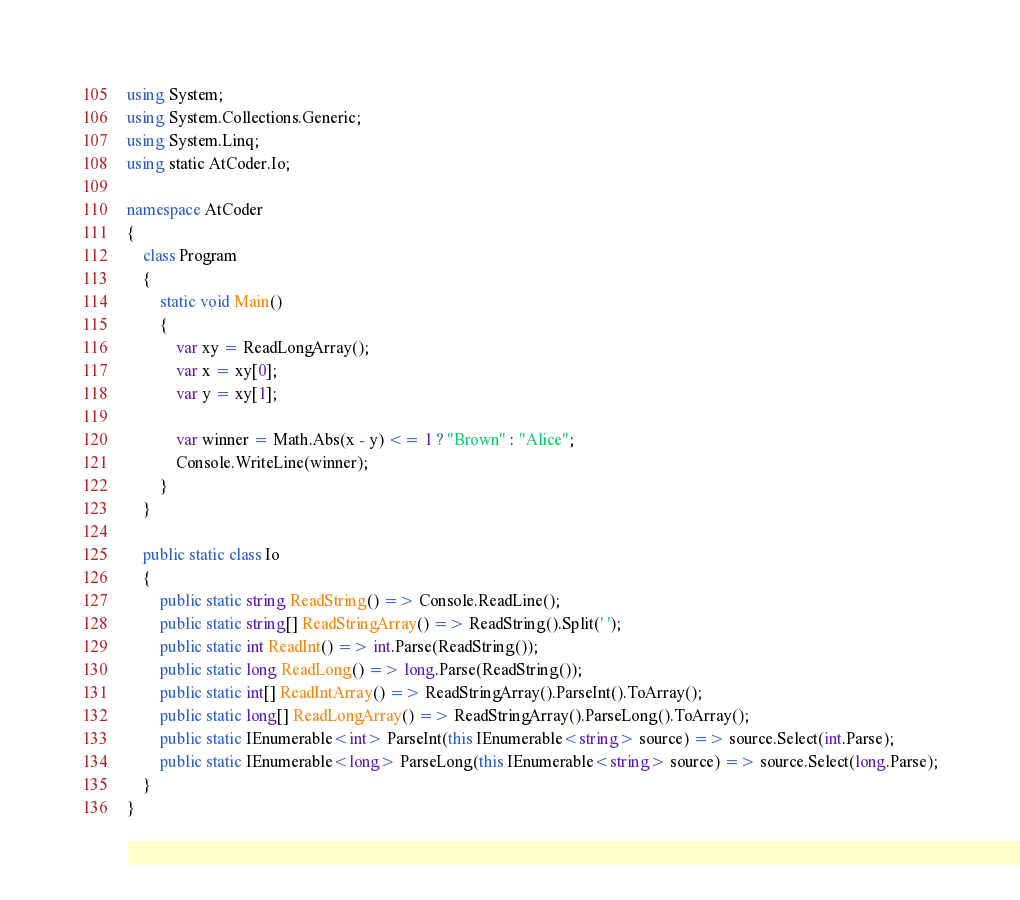Convert code to text. <code><loc_0><loc_0><loc_500><loc_500><_C#_>using System;
using System.Collections.Generic;
using System.Linq;
using static AtCoder.Io;

namespace AtCoder
{
    class Program
    {
        static void Main()
        {
            var xy = ReadLongArray();
            var x = xy[0];
            var y = xy[1];

            var winner = Math.Abs(x - y) <= 1 ? "Brown" : "Alice";
            Console.WriteLine(winner);
        }
    }

    public static class Io
    {
        public static string ReadString() => Console.ReadLine();
        public static string[] ReadStringArray() => ReadString().Split(' ');
        public static int ReadInt() => int.Parse(ReadString());
        public static long ReadLong() => long.Parse(ReadString());
        public static int[] ReadIntArray() => ReadStringArray().ParseInt().ToArray();
        public static long[] ReadLongArray() => ReadStringArray().ParseLong().ToArray();
        public static IEnumerable<int> ParseInt(this IEnumerable<string> source) => source.Select(int.Parse);
        public static IEnumerable<long> ParseLong(this IEnumerable<string> source) => source.Select(long.Parse);
    }
}
</code> 